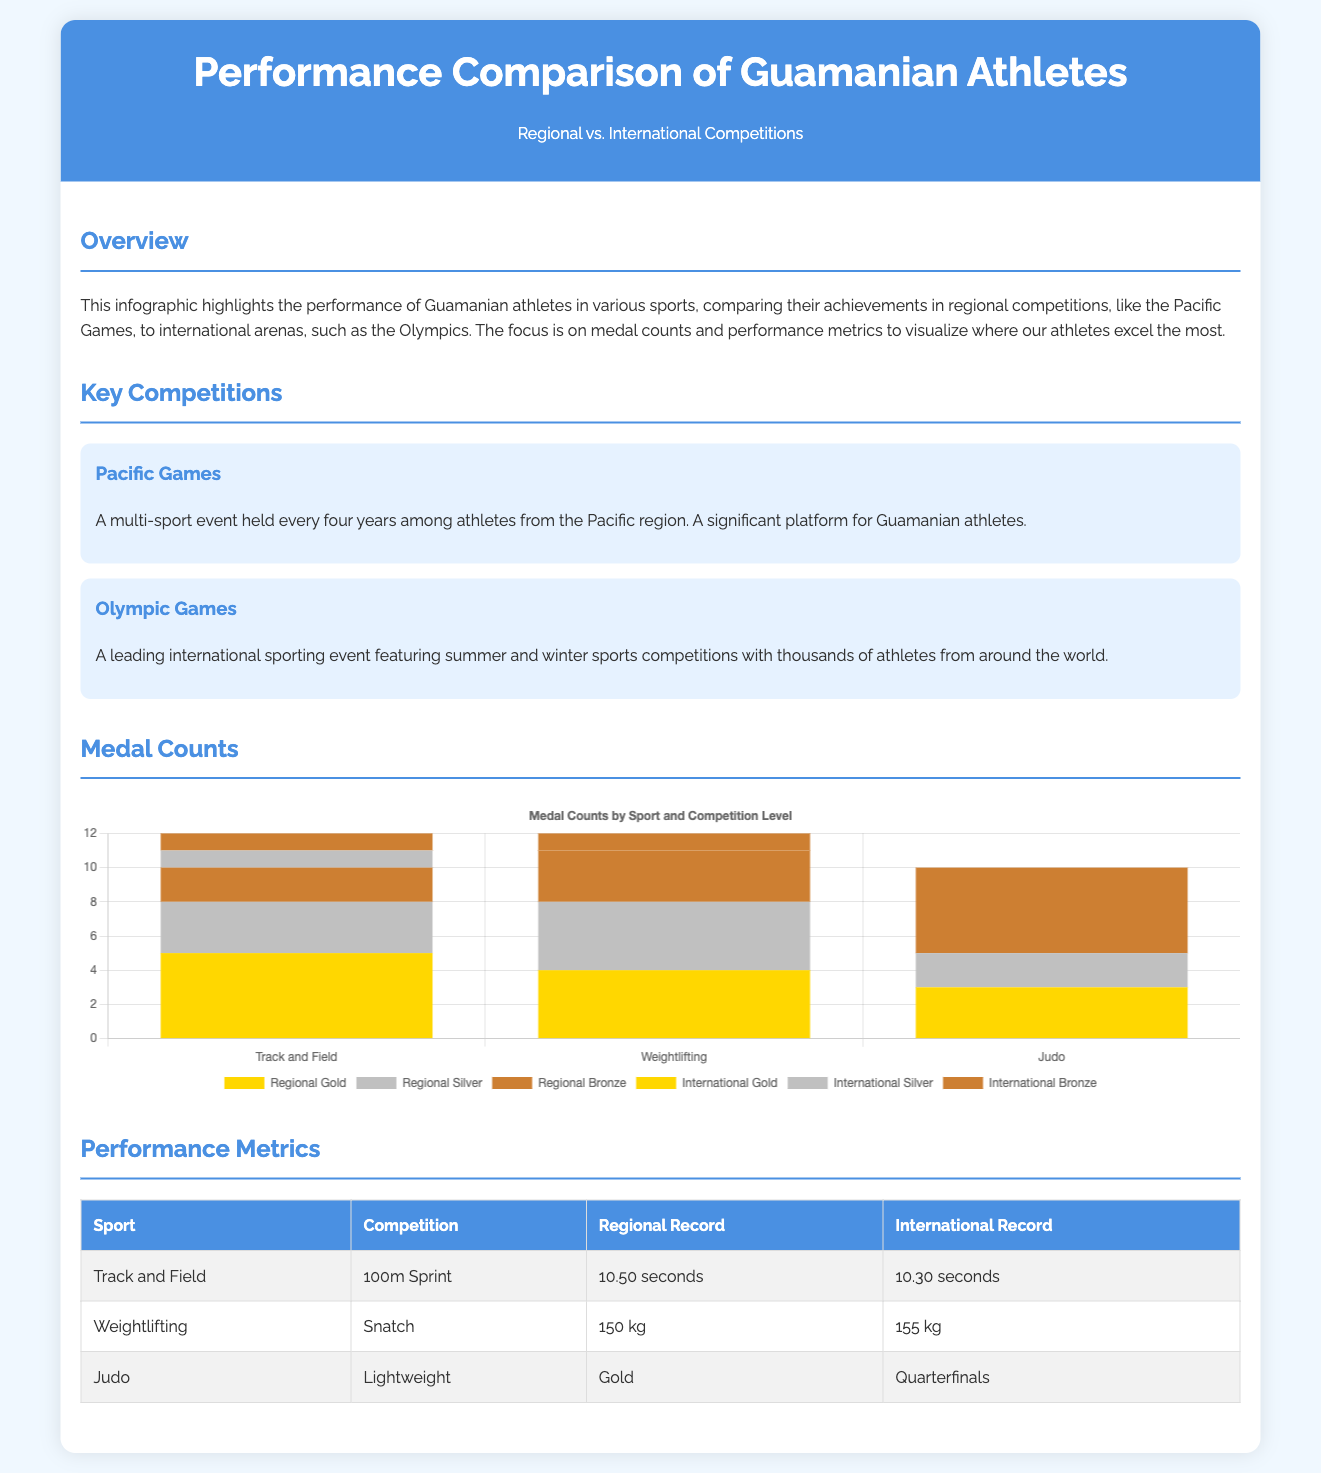what is the title of the infographic? The title of the infographic is clearly stated at the top of the document as "Performance Comparison of Guamanian Athletes".
Answer: Performance Comparison of Guamanian Athletes how many gold medals did Guamanian athletes win in Track and Field at the regional level? The medal counts in the chart show that Guamanian athletes won 5 gold medals in Track and Field at the regional level.
Answer: 5 what is the regional record time for the 100m Sprint? The table lists the Regional Record for the 100m Sprint in Track and Field as 10.50 seconds.
Answer: 10.50 seconds how many international bronze medals did Guamanian athletes win in Weightlifting? The chart indicates that Guamanian athletes won 1 international bronze medal in Weightlifting.
Answer: 1 which sport had the highest number of regional silver medals? The chart shows that Track and Field had the highest number of regional silver medals, totaling 3.
Answer: Track and Field how many international gold medals did Guamanian athletes win in Judo? The chart indicates that Guamanian athletes won 0 international gold medals in Judo.
Answer: 0 what is the main focus of the infographic? The infographic highlights the performance of Guamanian athletes in different sports, comparing their achievements in regional competitions and international arenas.
Answer: Performance metrics and medal counts what is the competition held every four years among athletes from the Pacific region? The document refers to the "Pacific Games" as the competition held every four years for athletes from the Pacific region.
Answer: Pacific Games how many sports are compared in the medal counts chart? There are three sports compared in the medal counts chart: Track and Field, Weightlifting, and Judo.
Answer: 3 